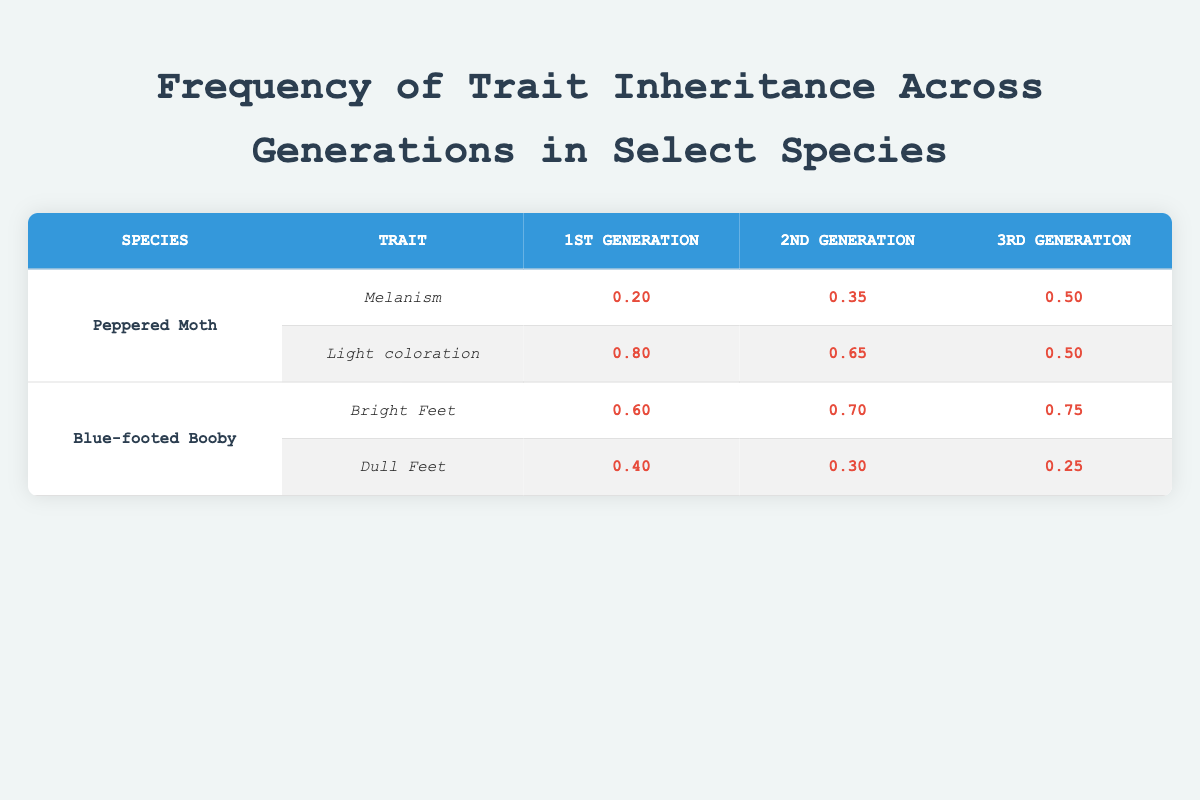What is the frequency of melanism in the 3rd generation of Peppered Moths? The table shows the frequency of melanism in the 3rd generation of Peppered Moths in the respective cell, which is 0.50.
Answer: 0.50 What trait has the highest frequency in the 1st generation of the Blue-footed Booby? From the table, "Bright Feet" has a frequency of 0.60 while "Dull Feet" has 0.40. Thus, "Bright Feet" has the highest frequency.
Answer: Bright Feet What is the difference in frequency of light coloration from the 1st generation to the 3rd generation of Peppered Moths? The frequency of light coloration in the 1st generation is 0.80, and in the 3rd generation it is 0.50. The difference is 0.80 - 0.50 = 0.30.
Answer: 0.30 Is the frequency of dull feet in the 2nd generation of the Blue-footed Booby higher than that in the 3rd generation? The table shows the frequency of dull feet in the 2nd generation is 0.30, while in the 3rd generation it is 0.25. Since 0.30 is greater than 0.25, the answer is yes.
Answer: Yes What is the average frequency of melanism across all generations of the Peppered Moth? The frequencies of melanism are 0.20 for the 1st generation, 0.35 for the 2nd, and 0.50 for the 3rd. Summing these gives 0.20 + 0.35 + 0.50 = 1.05. Dividing by 3 (the number of generations) gives an average of 1.05 / 3 = 0.35.
Answer: 0.35 What was the change in frequency of bright feet from the 1st to the 3rd generation of the Blue-footed Booby? The frequency of bright feet in the 1st generation is 0.60, and in the 3rd generation, it is 0.75. The change is 0.75 - 0.60 = 0.15.
Answer: 0.15 Does the frequency of light coloration in the 2nd generation of the Peppered Moth exceed 0.5? Checking the table, the frequency of light coloration in the 2nd generation is 0.65, which is greater than 0.5. Thus, the answer is yes.
Answer: Yes What is the total frequency for all the traits of the Blue-footed Booby in the 1st generation? From the table, the frequencies in the 1st generation are 0.60 for bright feet and 0.40 for dull feet. Adding them gives 0.60 + 0.40 = 1.00.
Answer: 1.00 What is the overall trend of melanism frequency across the generations for the Peppered Moth? Observing the frequencies: 0.20, 0.35, and 0.50 for the generations shows an increasing trend.
Answer: Increasing 